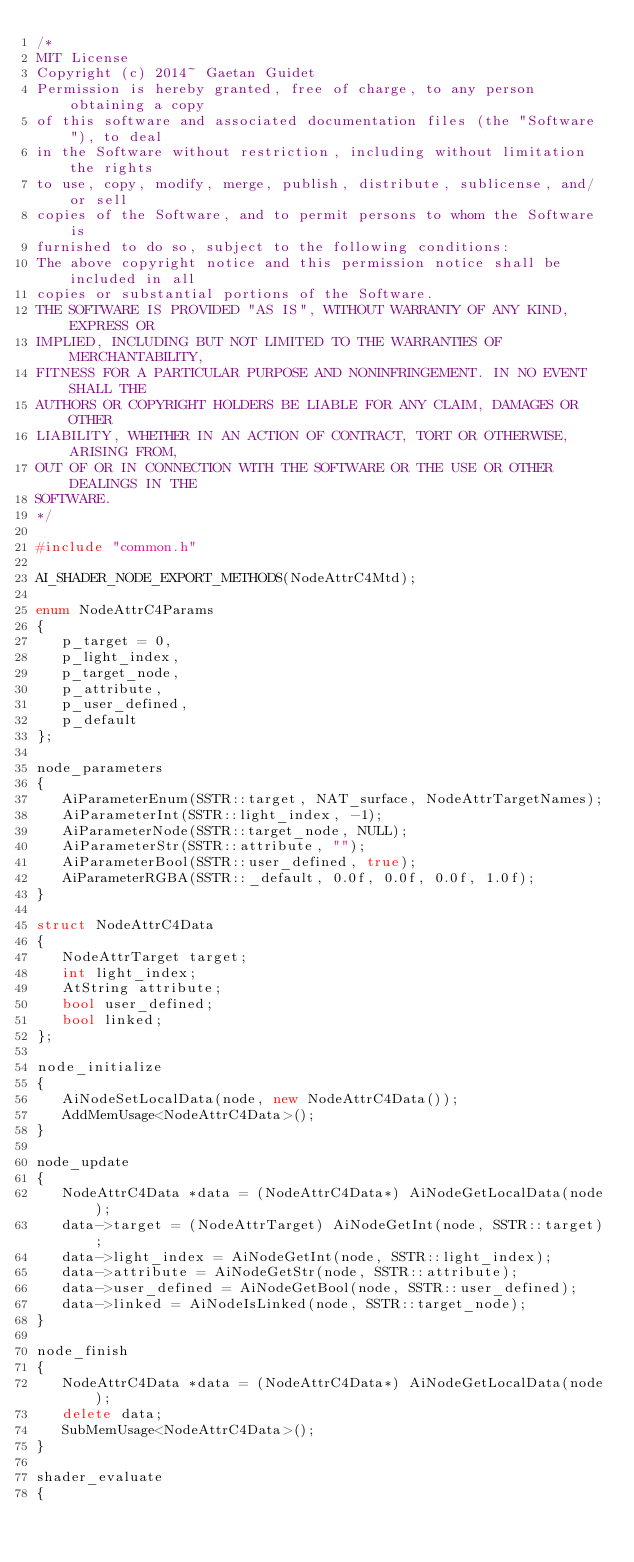<code> <loc_0><loc_0><loc_500><loc_500><_C++_>/*
MIT License
Copyright (c) 2014~ Gaetan Guidet
Permission is hereby granted, free of charge, to any person obtaining a copy
of this software and associated documentation files (the "Software"), to deal
in the Software without restriction, including without limitation the rights
to use, copy, modify, merge, publish, distribute, sublicense, and/or sell
copies of the Software, and to permit persons to whom the Software is
furnished to do so, subject to the following conditions:
The above copyright notice and this permission notice shall be included in all
copies or substantial portions of the Software.
THE SOFTWARE IS PROVIDED "AS IS", WITHOUT WARRANTY OF ANY KIND, EXPRESS OR
IMPLIED, INCLUDING BUT NOT LIMITED TO THE WARRANTIES OF MERCHANTABILITY,
FITNESS FOR A PARTICULAR PURPOSE AND NONINFRINGEMENT. IN NO EVENT SHALL THE
AUTHORS OR COPYRIGHT HOLDERS BE LIABLE FOR ANY CLAIM, DAMAGES OR OTHER
LIABILITY, WHETHER IN AN ACTION OF CONTRACT, TORT OR OTHERWISE, ARISING FROM,
OUT OF OR IN CONNECTION WITH THE SOFTWARE OR THE USE OR OTHER DEALINGS IN THE
SOFTWARE.
*/

#include "common.h"

AI_SHADER_NODE_EXPORT_METHODS(NodeAttrC4Mtd);

enum NodeAttrC4Params
{
   p_target = 0,
   p_light_index,
   p_target_node,
   p_attribute,
   p_user_defined,
   p_default
};

node_parameters
{
   AiParameterEnum(SSTR::target, NAT_surface, NodeAttrTargetNames);
   AiParameterInt(SSTR::light_index, -1);
   AiParameterNode(SSTR::target_node, NULL);
   AiParameterStr(SSTR::attribute, "");
   AiParameterBool(SSTR::user_defined, true);
   AiParameterRGBA(SSTR::_default, 0.0f, 0.0f, 0.0f, 1.0f);
}

struct NodeAttrC4Data
{
   NodeAttrTarget target;
   int light_index;
   AtString attribute;
   bool user_defined;
   bool linked;
};

node_initialize
{
   AiNodeSetLocalData(node, new NodeAttrC4Data());
   AddMemUsage<NodeAttrC4Data>();
}

node_update
{
   NodeAttrC4Data *data = (NodeAttrC4Data*) AiNodeGetLocalData(node);
   data->target = (NodeAttrTarget) AiNodeGetInt(node, SSTR::target);
   data->light_index = AiNodeGetInt(node, SSTR::light_index);
   data->attribute = AiNodeGetStr(node, SSTR::attribute);
   data->user_defined = AiNodeGetBool(node, SSTR::user_defined);
   data->linked = AiNodeIsLinked(node, SSTR::target_node);
}

node_finish
{
   NodeAttrC4Data *data = (NodeAttrC4Data*) AiNodeGetLocalData(node);
   delete data;
   SubMemUsage<NodeAttrC4Data>();
}

shader_evaluate
{</code> 